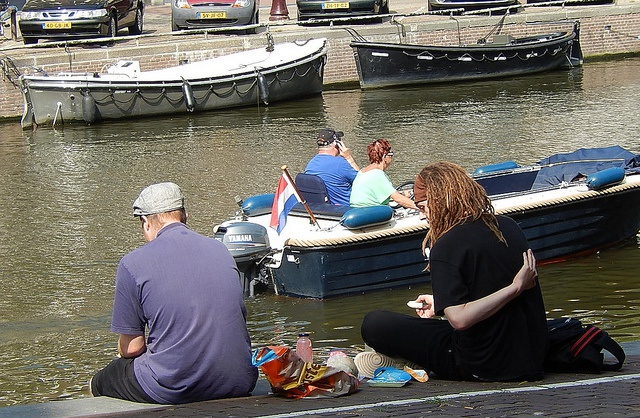Describe the objects in this image and their specific colors. I can see boat in black, white, gray, and darkgray tones, people in black, maroon, and gray tones, people in black, gray, and purple tones, boat in black, white, gray, and darkgray tones, and boat in black, gray, darkgray, and lightgray tones in this image. 